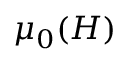<formula> <loc_0><loc_0><loc_500><loc_500>\mu _ { 0 } ( H )</formula> 